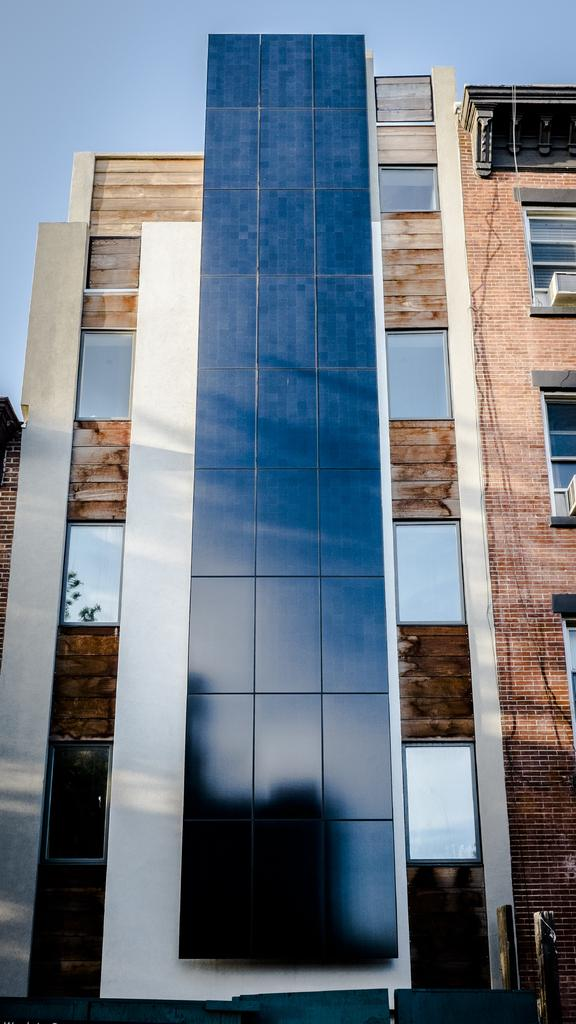Where was the image taken? The image was taken outdoors. What can be seen at the top of the image? The sky is visible at the top of the image. What is the main structure in the middle of the image? There is a building in the middle of the image. What are some features of the building? The building has walls, windows, and glasses (possibly referring to window panes). It also has a roof. What type of song can be heard coming from the building in the image? There is no indication of any sound or song in the image, as it only shows a building with its features. 